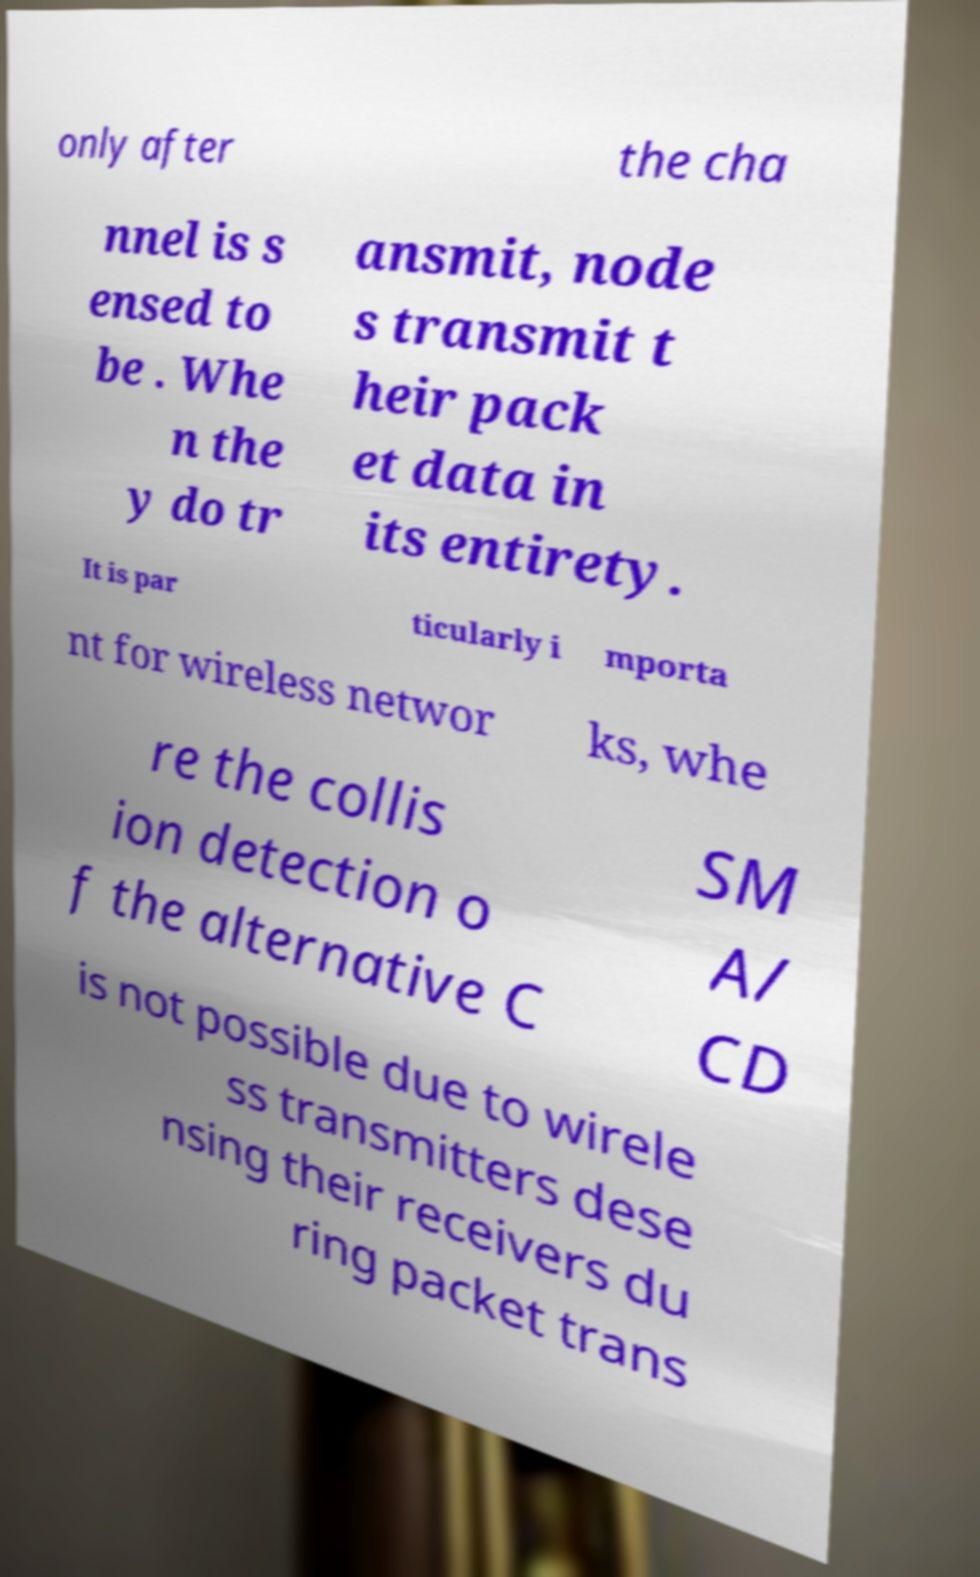For documentation purposes, I need the text within this image transcribed. Could you provide that? only after the cha nnel is s ensed to be . Whe n the y do tr ansmit, node s transmit t heir pack et data in its entirety. It is par ticularly i mporta nt for wireless networ ks, whe re the collis ion detection o f the alternative C SM A/ CD is not possible due to wirele ss transmitters dese nsing their receivers du ring packet trans 